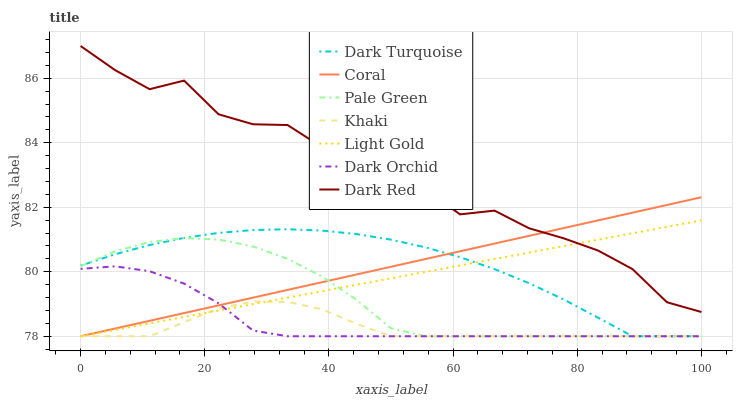Does Khaki have the minimum area under the curve?
Answer yes or no. Yes. Does Dark Red have the maximum area under the curve?
Answer yes or no. Yes. Does Dark Turquoise have the minimum area under the curve?
Answer yes or no. No. Does Dark Turquoise have the maximum area under the curve?
Answer yes or no. No. Is Coral the smoothest?
Answer yes or no. Yes. Is Dark Red the roughest?
Answer yes or no. Yes. Is Dark Turquoise the smoothest?
Answer yes or no. No. Is Dark Turquoise the roughest?
Answer yes or no. No. Does Khaki have the lowest value?
Answer yes or no. Yes. Does Dark Red have the lowest value?
Answer yes or no. No. Does Dark Red have the highest value?
Answer yes or no. Yes. Does Dark Turquoise have the highest value?
Answer yes or no. No. Is Dark Turquoise less than Dark Red?
Answer yes or no. Yes. Is Dark Red greater than Pale Green?
Answer yes or no. Yes. Does Dark Turquoise intersect Dark Orchid?
Answer yes or no. Yes. Is Dark Turquoise less than Dark Orchid?
Answer yes or no. No. Is Dark Turquoise greater than Dark Orchid?
Answer yes or no. No. Does Dark Turquoise intersect Dark Red?
Answer yes or no. No. 